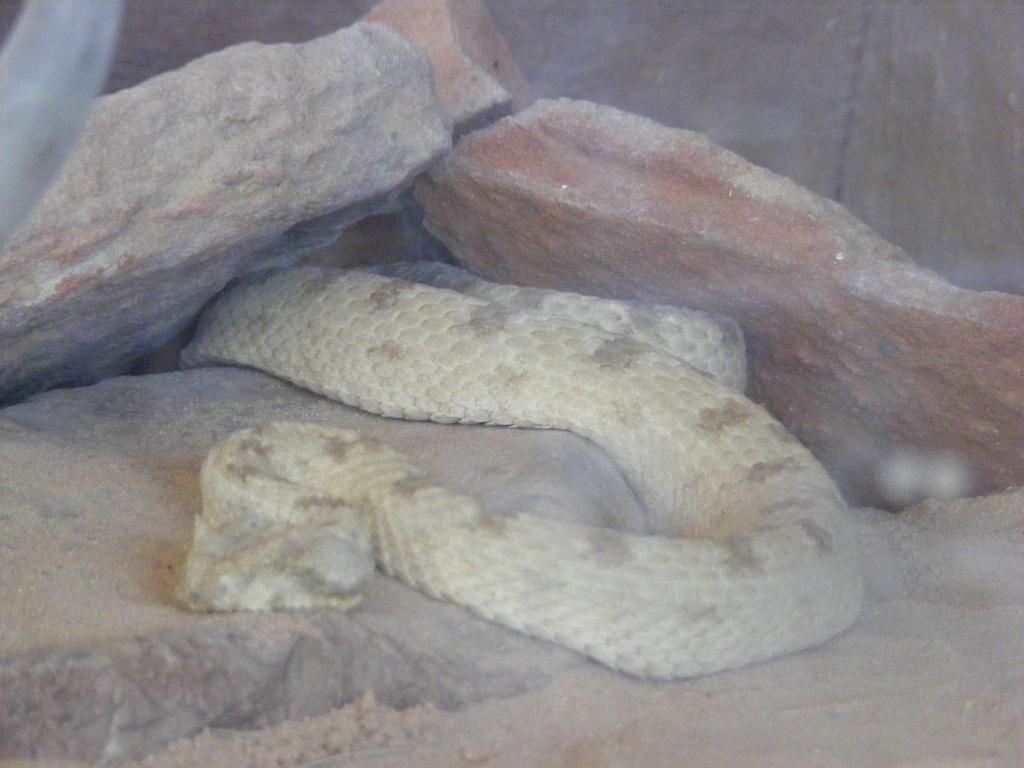What is the main subject in the middle of the image? There is a snake in the middle of the image. What can be seen in the background of the image? There are stones in the background of the image. What is the interest rate of the hospital in the image? There is no hospital present in the image, and therefore no interest rate can be determined. 